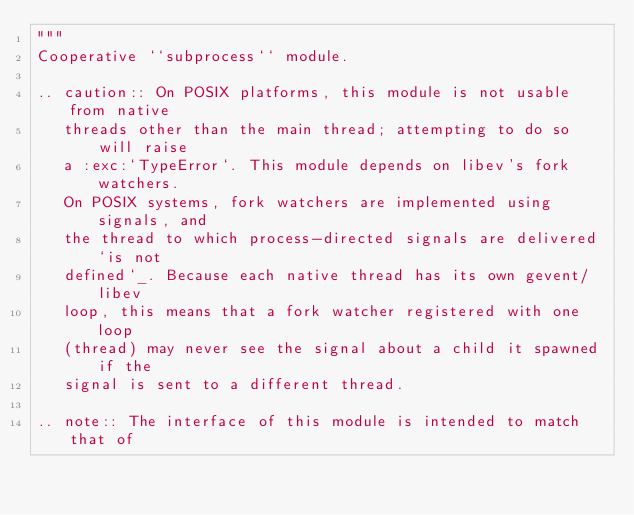<code> <loc_0><loc_0><loc_500><loc_500><_Python_>"""
Cooperative ``subprocess`` module.

.. caution:: On POSIX platforms, this module is not usable from native
   threads other than the main thread; attempting to do so will raise
   a :exc:`TypeError`. This module depends on libev's fork watchers.
   On POSIX systems, fork watchers are implemented using signals, and
   the thread to which process-directed signals are delivered `is not
   defined`_. Because each native thread has its own gevent/libev
   loop, this means that a fork watcher registered with one loop
   (thread) may never see the signal about a child it spawned if the
   signal is sent to a different thread.

.. note:: The interface of this module is intended to match that of</code> 